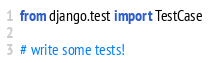Convert code to text. <code><loc_0><loc_0><loc_500><loc_500><_Python_>from django.test import TestCase

# write some tests!
</code> 